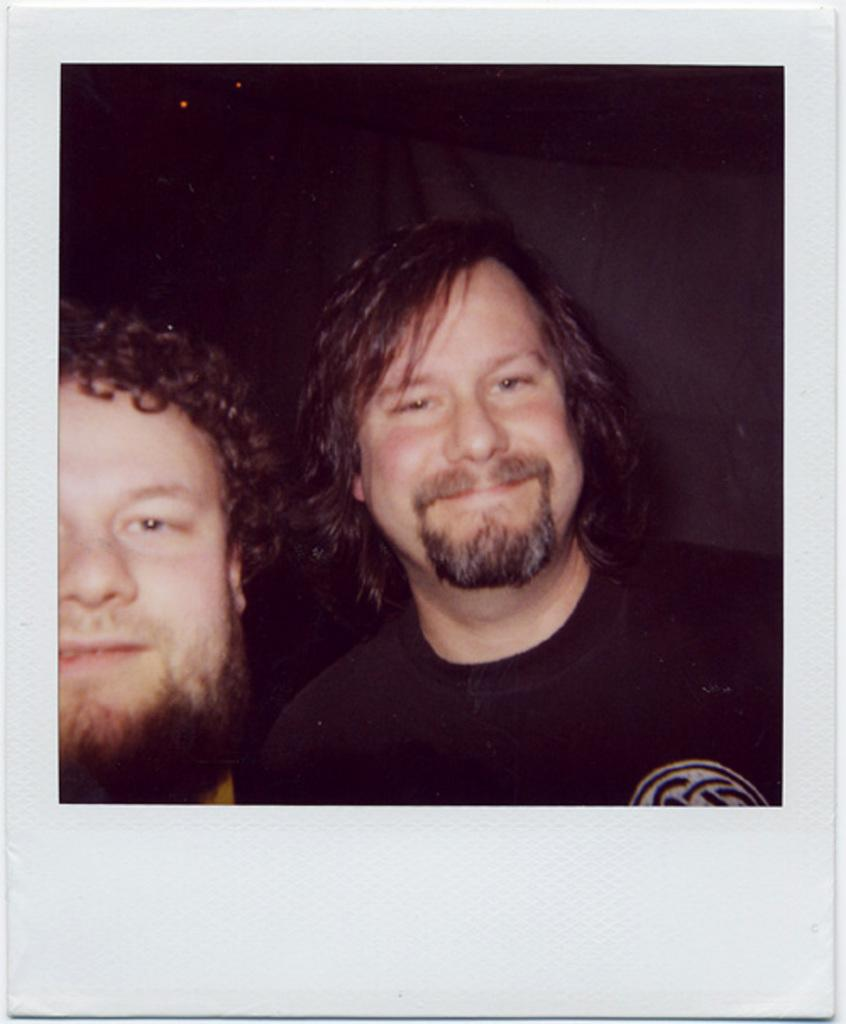How many people are present in the image? There are two men in the image. What type of steel is being used to construct the chair in the image? There is no chair present in the image, so it is not possible to determine what type of steel might be used. 